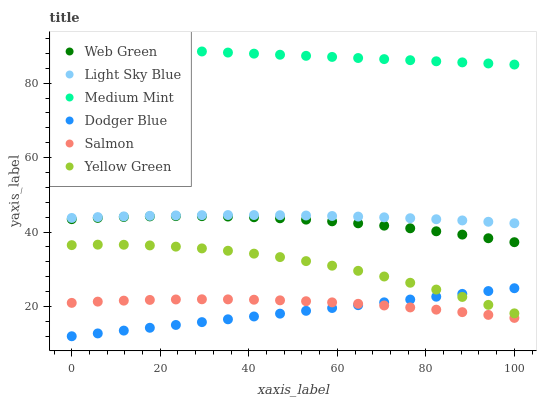Does Dodger Blue have the minimum area under the curve?
Answer yes or no. Yes. Does Medium Mint have the maximum area under the curve?
Answer yes or no. Yes. Does Yellow Green have the minimum area under the curve?
Answer yes or no. No. Does Yellow Green have the maximum area under the curve?
Answer yes or no. No. Is Dodger Blue the smoothest?
Answer yes or no. Yes. Is Yellow Green the roughest?
Answer yes or no. Yes. Is Salmon the smoothest?
Answer yes or no. No. Is Salmon the roughest?
Answer yes or no. No. Does Dodger Blue have the lowest value?
Answer yes or no. Yes. Does Yellow Green have the lowest value?
Answer yes or no. No. Does Medium Mint have the highest value?
Answer yes or no. Yes. Does Yellow Green have the highest value?
Answer yes or no. No. Is Web Green less than Light Sky Blue?
Answer yes or no. Yes. Is Web Green greater than Yellow Green?
Answer yes or no. Yes. Does Dodger Blue intersect Salmon?
Answer yes or no. Yes. Is Dodger Blue less than Salmon?
Answer yes or no. No. Is Dodger Blue greater than Salmon?
Answer yes or no. No. Does Web Green intersect Light Sky Blue?
Answer yes or no. No. 